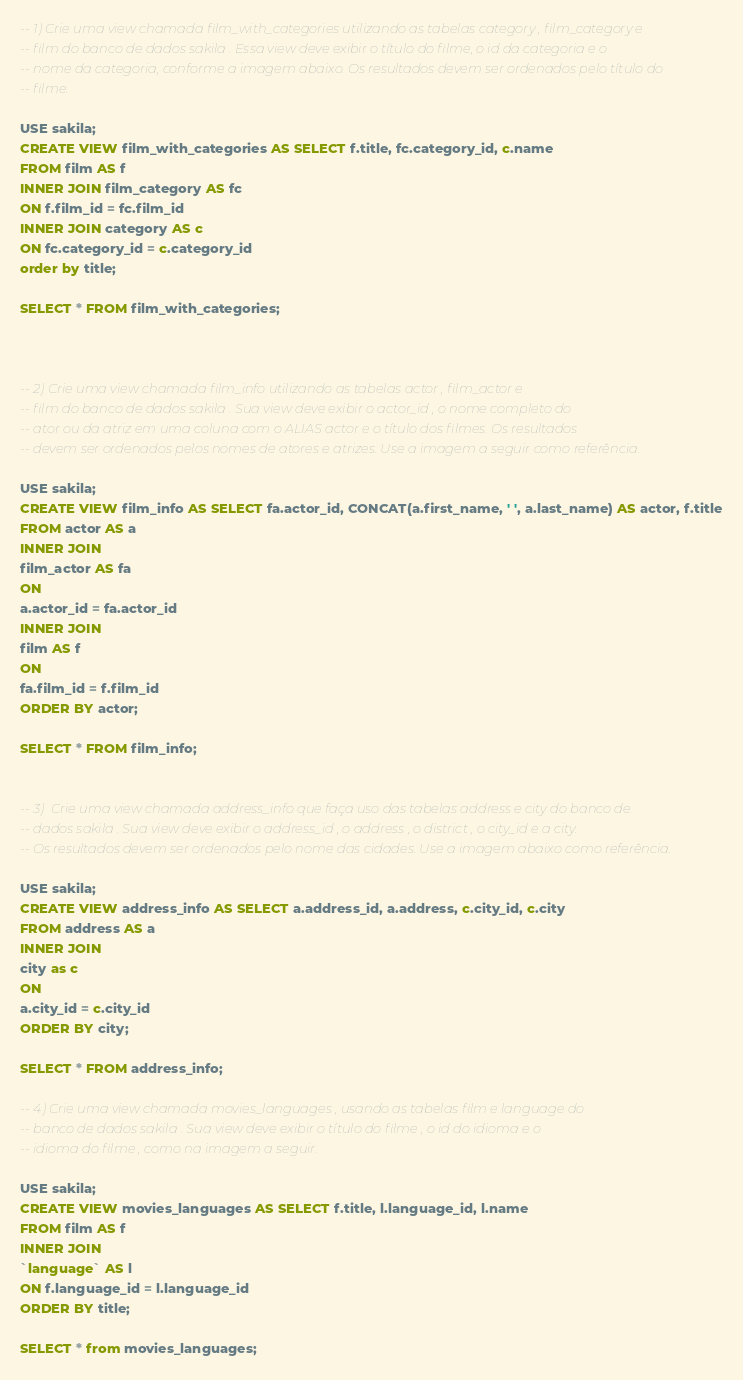Convert code to text. <code><loc_0><loc_0><loc_500><loc_500><_SQL_>-- 1) Crie uma view chamada film_with_categories utilizando as tabelas category , film_category e 
-- film do banco de dados sakila . Essa view deve exibir o título do filme, o id da categoria e o 
-- nome da categoria, conforme a imagem abaixo. Os resultados devem ser ordenados pelo título do 
-- filme.

USE sakila;
CREATE VIEW film_with_categories AS SELECT f.title, fc.category_id, c.name 
FROM film AS f
INNER JOIN film_category AS fc
ON f.film_id = fc.film_id
INNER JOIN category AS c
ON fc.category_id = c.category_id
order by title;

SELECT * FROM film_with_categories;



-- 2) Crie uma view chamada film_info utilizando as tabelas actor , film_actor e 
-- film do banco de dados sakila . Sua view deve exibir o actor_id , o nome completo do 
-- ator ou da atriz em uma coluna com o ALIAS actor e o título dos filmes. Os resultados 
-- devem ser ordenados pelos nomes de atores e atrizes. Use a imagem a seguir como referência.

USE sakila;
CREATE VIEW film_info AS SELECT fa.actor_id, CONCAT(a.first_name, ' ', a.last_name) AS actor, f.title
FROM actor AS a
INNER JOIN
film_actor AS fa
ON 
a.actor_id = fa.actor_id
INNER JOIN 
film AS f
ON 
fa.film_id = f.film_id
ORDER BY actor;

SELECT * FROM film_info;


-- 3)  Crie uma view chamada address_info que faça uso das tabelas address e city do banco de 
-- dados sakila . Sua view deve exibir o address_id , o address , o district , o city_id e a city.
-- Os resultados devem ser ordenados pelo nome das cidades. Use a imagem abaixo como referência.

USE sakila;
CREATE VIEW address_info AS SELECT a.address_id, a.address, c.city_id, c.city 
FROM address AS a
INNER JOIN 
city as c
ON 
a.city_id = c.city_id
ORDER BY city;

SELECT * FROM address_info;

-- 4) Crie uma view chamada movies_languages , usando as tabelas film e language do 
-- banco de dados sakila . Sua view deve exibir o título do filme , o id do idioma e o 
-- idioma do filme , como na imagem a seguir.

USE sakila; 
CREATE VIEW movies_languages AS SELECT f.title, l.language_id, l.name
FROM film AS f
INNER JOIN 
`language` AS l
ON f.language_id = l.language_id
ORDER BY title;

SELECT * from movies_languages;</code> 